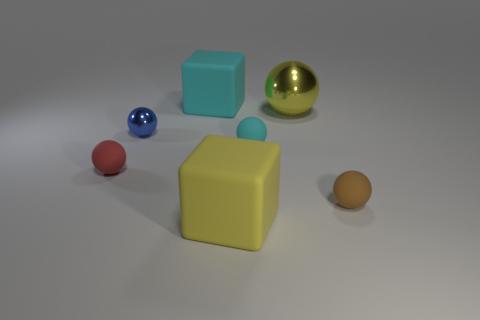There is a sphere that is in front of the red matte thing; is its size the same as the tiny shiny ball?
Give a very brief answer. Yes. What number of blue rubber cylinders are the same size as the yellow cube?
Give a very brief answer. 0. The small red thing is what shape?
Your answer should be compact. Sphere. Are there any big spheres of the same color as the small metal ball?
Make the answer very short. No. Is the number of large yellow balls right of the yellow rubber object greater than the number of purple shiny blocks?
Keep it short and to the point. Yes. There is a yellow shiny thing; is it the same shape as the cyan matte thing in front of the big cyan cube?
Offer a very short reply. Yes. Are any tiny yellow metallic cubes visible?
Your response must be concise. No. What number of large things are cyan cubes or yellow cubes?
Give a very brief answer. 2. Is the number of red things that are behind the small cyan sphere greater than the number of tiny metal things on the left side of the blue ball?
Ensure brevity in your answer.  No. Do the tiny blue object and the big yellow object behind the red rubber ball have the same material?
Make the answer very short. Yes. 